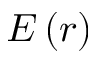<formula> <loc_0><loc_0><loc_500><loc_500>E \left ( r \right )</formula> 